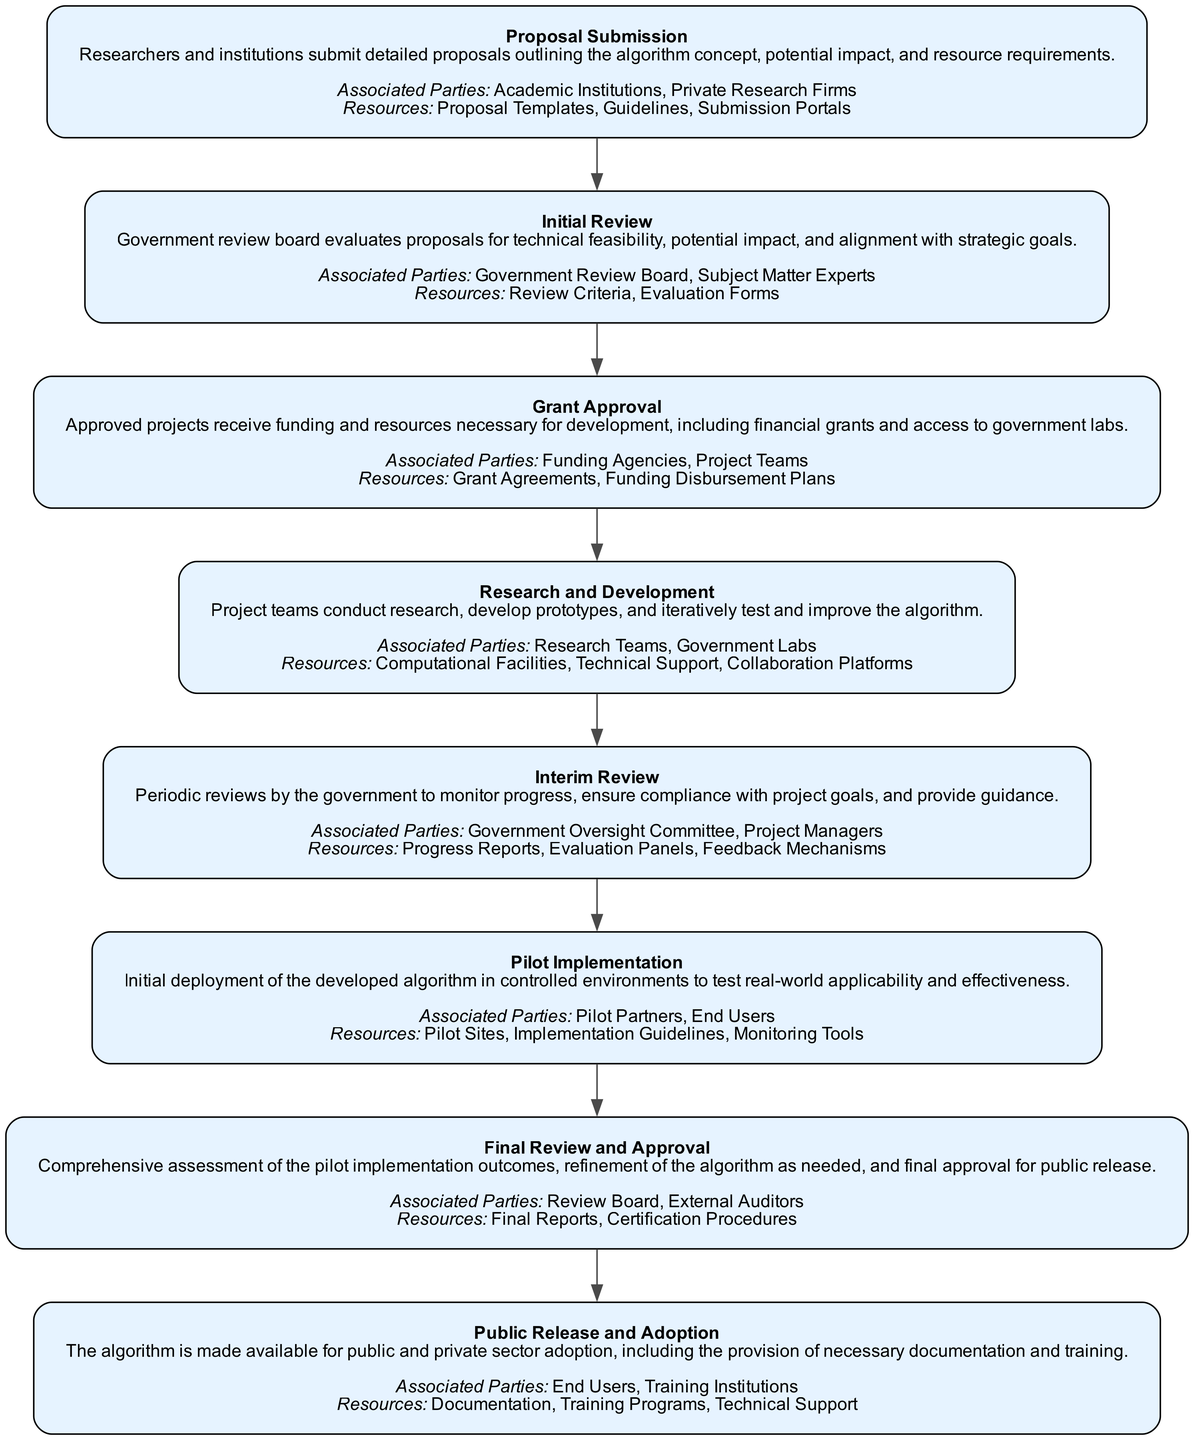What is the first step in the lifecycle? The first step in the lifecycle is titled "Proposal Submission" and is discussed at the top of the diagram. It is the initial stage where researchers submit proposals.
Answer: Proposal Submission How many total steps are in the lifecycle? The diagram outlines a total of 8 distinct steps, which can be counted from the top to the bottom of the visual representation.
Answer: 8 What resources are associated with Final Review and Approval? In the diagram, associated resources for this step include "Final Reports" and "Certification Procedures," which are directly mentioned under that step.
Answer: Final Reports, Certification Procedures Who are the associated parties in the Research and Development phase? The diagram specifies "Research Teams" and "Government Labs" as the associated parties under the Research and Development section.
Answer: Research Teams, Government Labs What comes after Grant Approval? According to the sequential flow indicated in the diagram, "Research and Development" follows directly after the Grant Approval step.
Answer: Research and Development Which parties are involved in the Pilot Implementation? The diagram highlights "Pilot Partners" and "End Users" as the parties associated with the Pilot Implementation phase.
Answer: Pilot Partners, End Users What is the primary purpose of the Interim Review? The purpose of the Interim Review, as stated in the diagram, is to monitor progress and ensure compliance with project goals through periodic reviews.
Answer: Monitor progress, ensure compliance Which phase involves the final assessment of the algorithm? The phase that includes the final assessment of the algorithm is labeled "Final Review and Approval," which indicates it is the concluding evaluation stage.
Answer: Final Review and Approval What is the last step of the lifecycle? The last step in the lifecycle of the project, according to the diagram, is "Public Release and Adoption." This signifies the completion of the process and the algorithm's availability.
Answer: Public Release and Adoption 